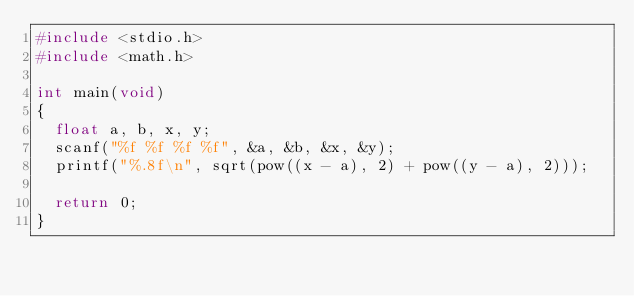Convert code to text. <code><loc_0><loc_0><loc_500><loc_500><_C_>#include <stdio.h>
#include <math.h>

int main(void)
{
  float a, b, x, y;
  scanf("%f %f %f %f", &a, &b, &x, &y);
  printf("%.8f\n", sqrt(pow((x - a), 2) + pow((y - a), 2)));
  
  return 0;
}</code> 